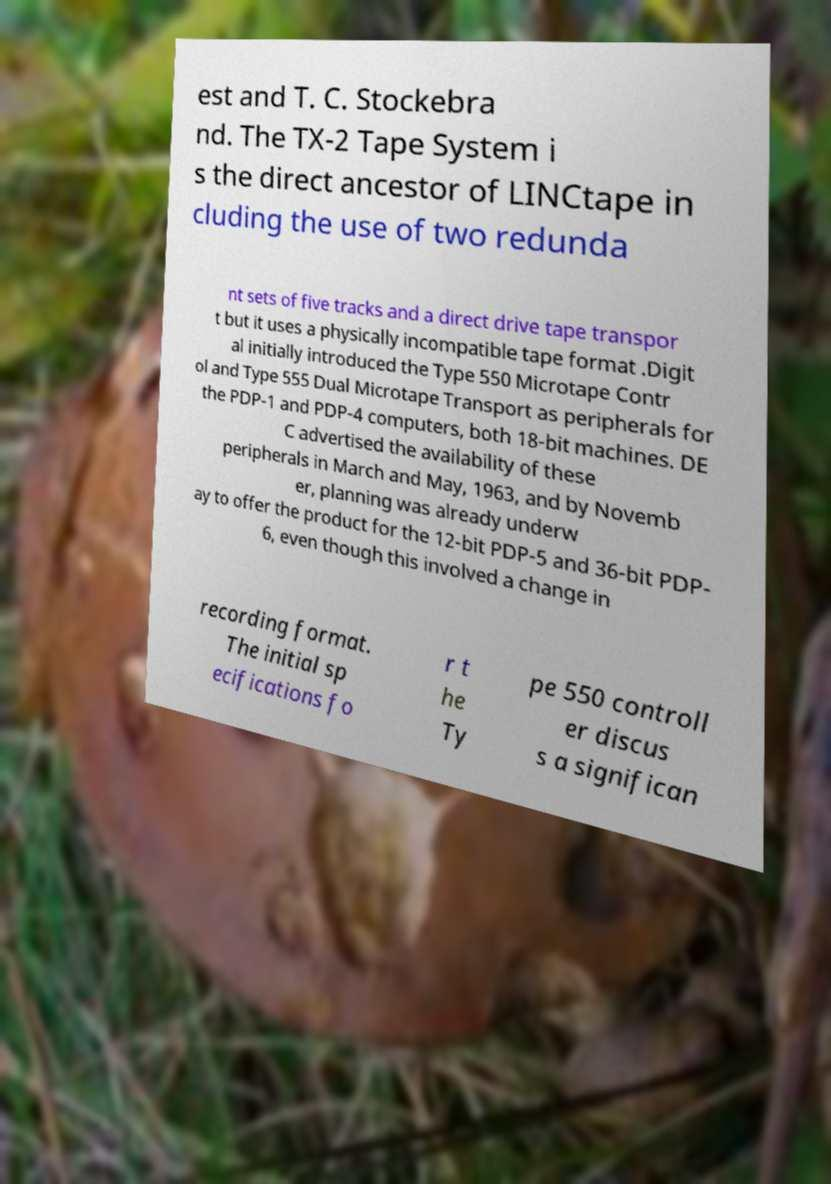Please identify and transcribe the text found in this image. est and T. C. Stockebra nd. The TX-2 Tape System i s the direct ancestor of LINCtape in cluding the use of two redunda nt sets of five tracks and a direct drive tape transpor t but it uses a physically incompatible tape format .Digit al initially introduced the Type 550 Microtape Contr ol and Type 555 Dual Microtape Transport as peripherals for the PDP-1 and PDP-4 computers, both 18-bit machines. DE C advertised the availability of these peripherals in March and May, 1963, and by Novemb er, planning was already underw ay to offer the product for the 12-bit PDP-5 and 36-bit PDP- 6, even though this involved a change in recording format. The initial sp ecifications fo r t he Ty pe 550 controll er discus s a significan 